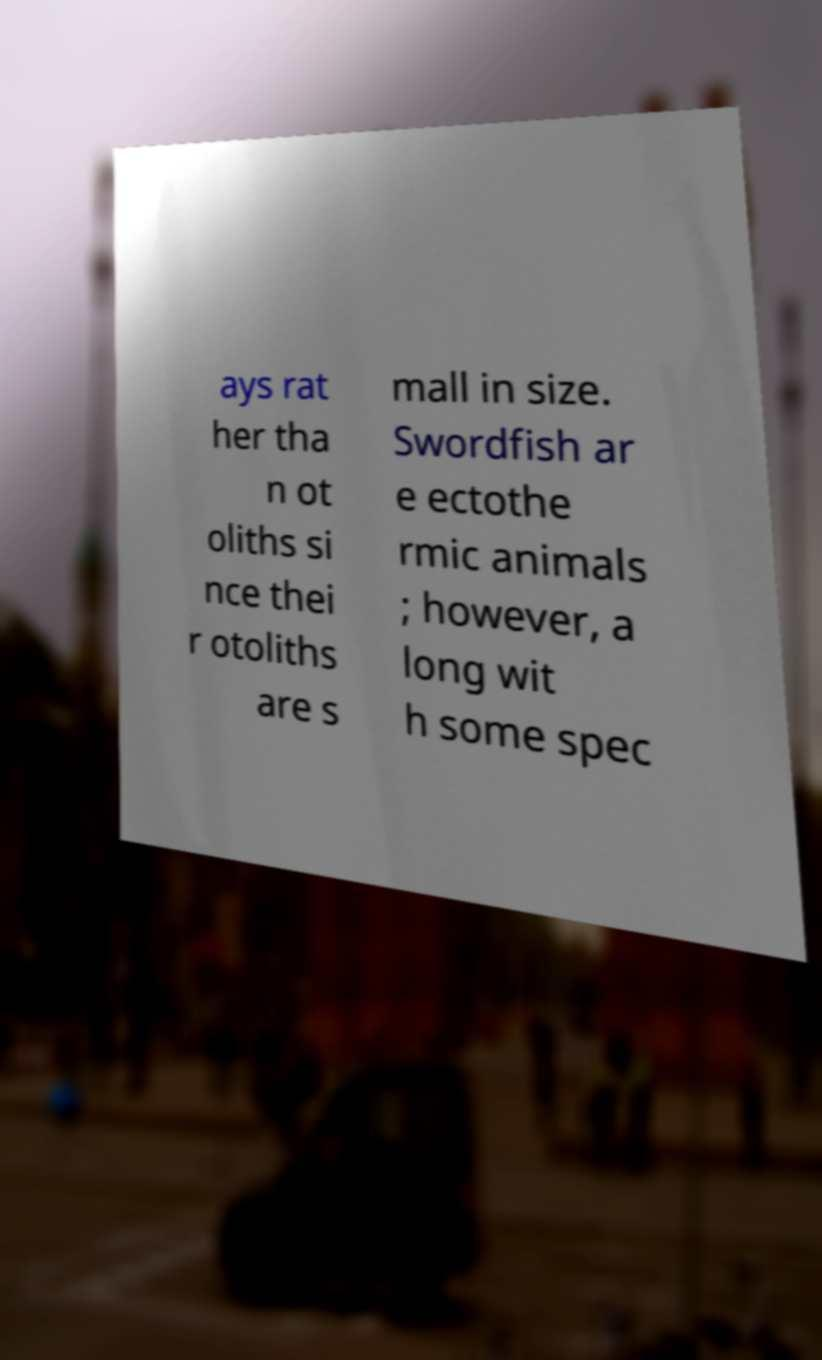For documentation purposes, I need the text within this image transcribed. Could you provide that? ays rat her tha n ot oliths si nce thei r otoliths are s mall in size. Swordfish ar e ectothe rmic animals ; however, a long wit h some spec 